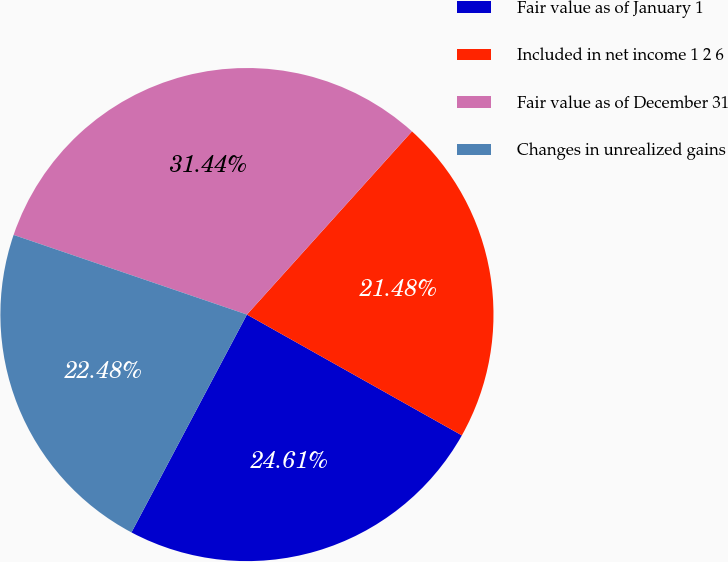Convert chart. <chart><loc_0><loc_0><loc_500><loc_500><pie_chart><fcel>Fair value as of January 1<fcel>Included in net income 1 2 6<fcel>Fair value as of December 31<fcel>Changes in unrealized gains<nl><fcel>24.61%<fcel>21.48%<fcel>31.44%<fcel>22.48%<nl></chart> 